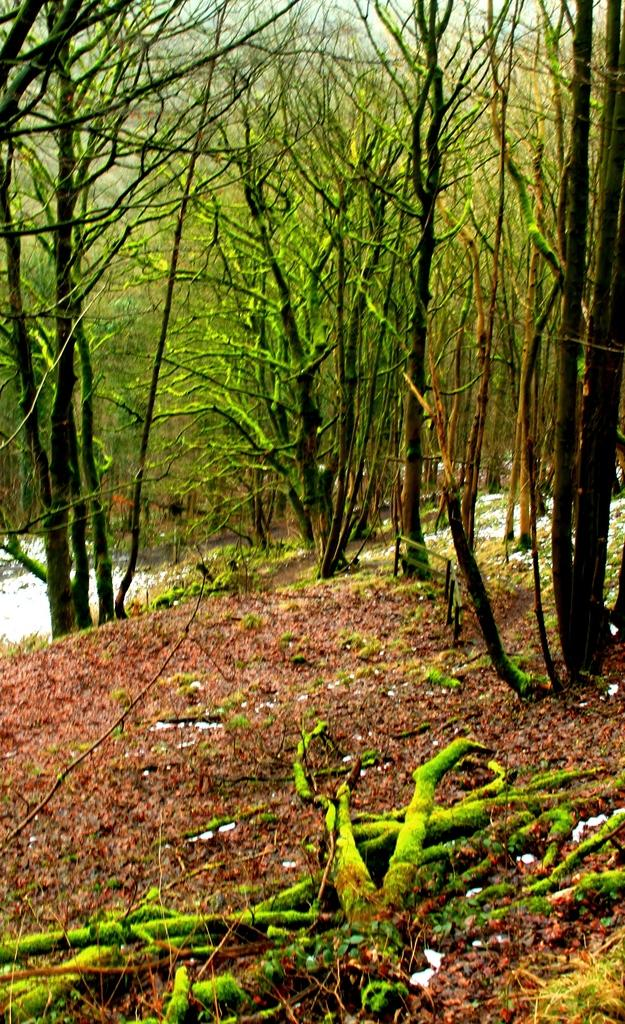What type of vegetation is in the middle of the image? There are tall trees in the middle of the image. What is visible at the bottom of the image? There is a ground at the bottom of the image. What can be seen on the ground beneath the trees? Tree stems are present on the ground, and dry leaves are visible on the ground. What type of flame can be seen burning on the ground in the image? There is no flame present in the image; it features tall trees, a ground, tree stems, and dry leaves. What sound can be heard from a whistle in the image? There is no whistle present in the image, so no sound can be heard. 